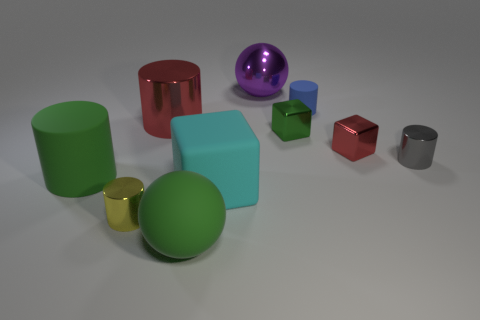Subtract all cyan cylinders. Subtract all gray spheres. How many cylinders are left? 5 Subtract all cubes. How many objects are left? 7 Add 9 small blue cylinders. How many small blue cylinders exist? 10 Subtract 0 gray spheres. How many objects are left? 10 Subtract all small yellow rubber objects. Subtract all yellow metallic things. How many objects are left? 9 Add 1 small metal objects. How many small metal objects are left? 5 